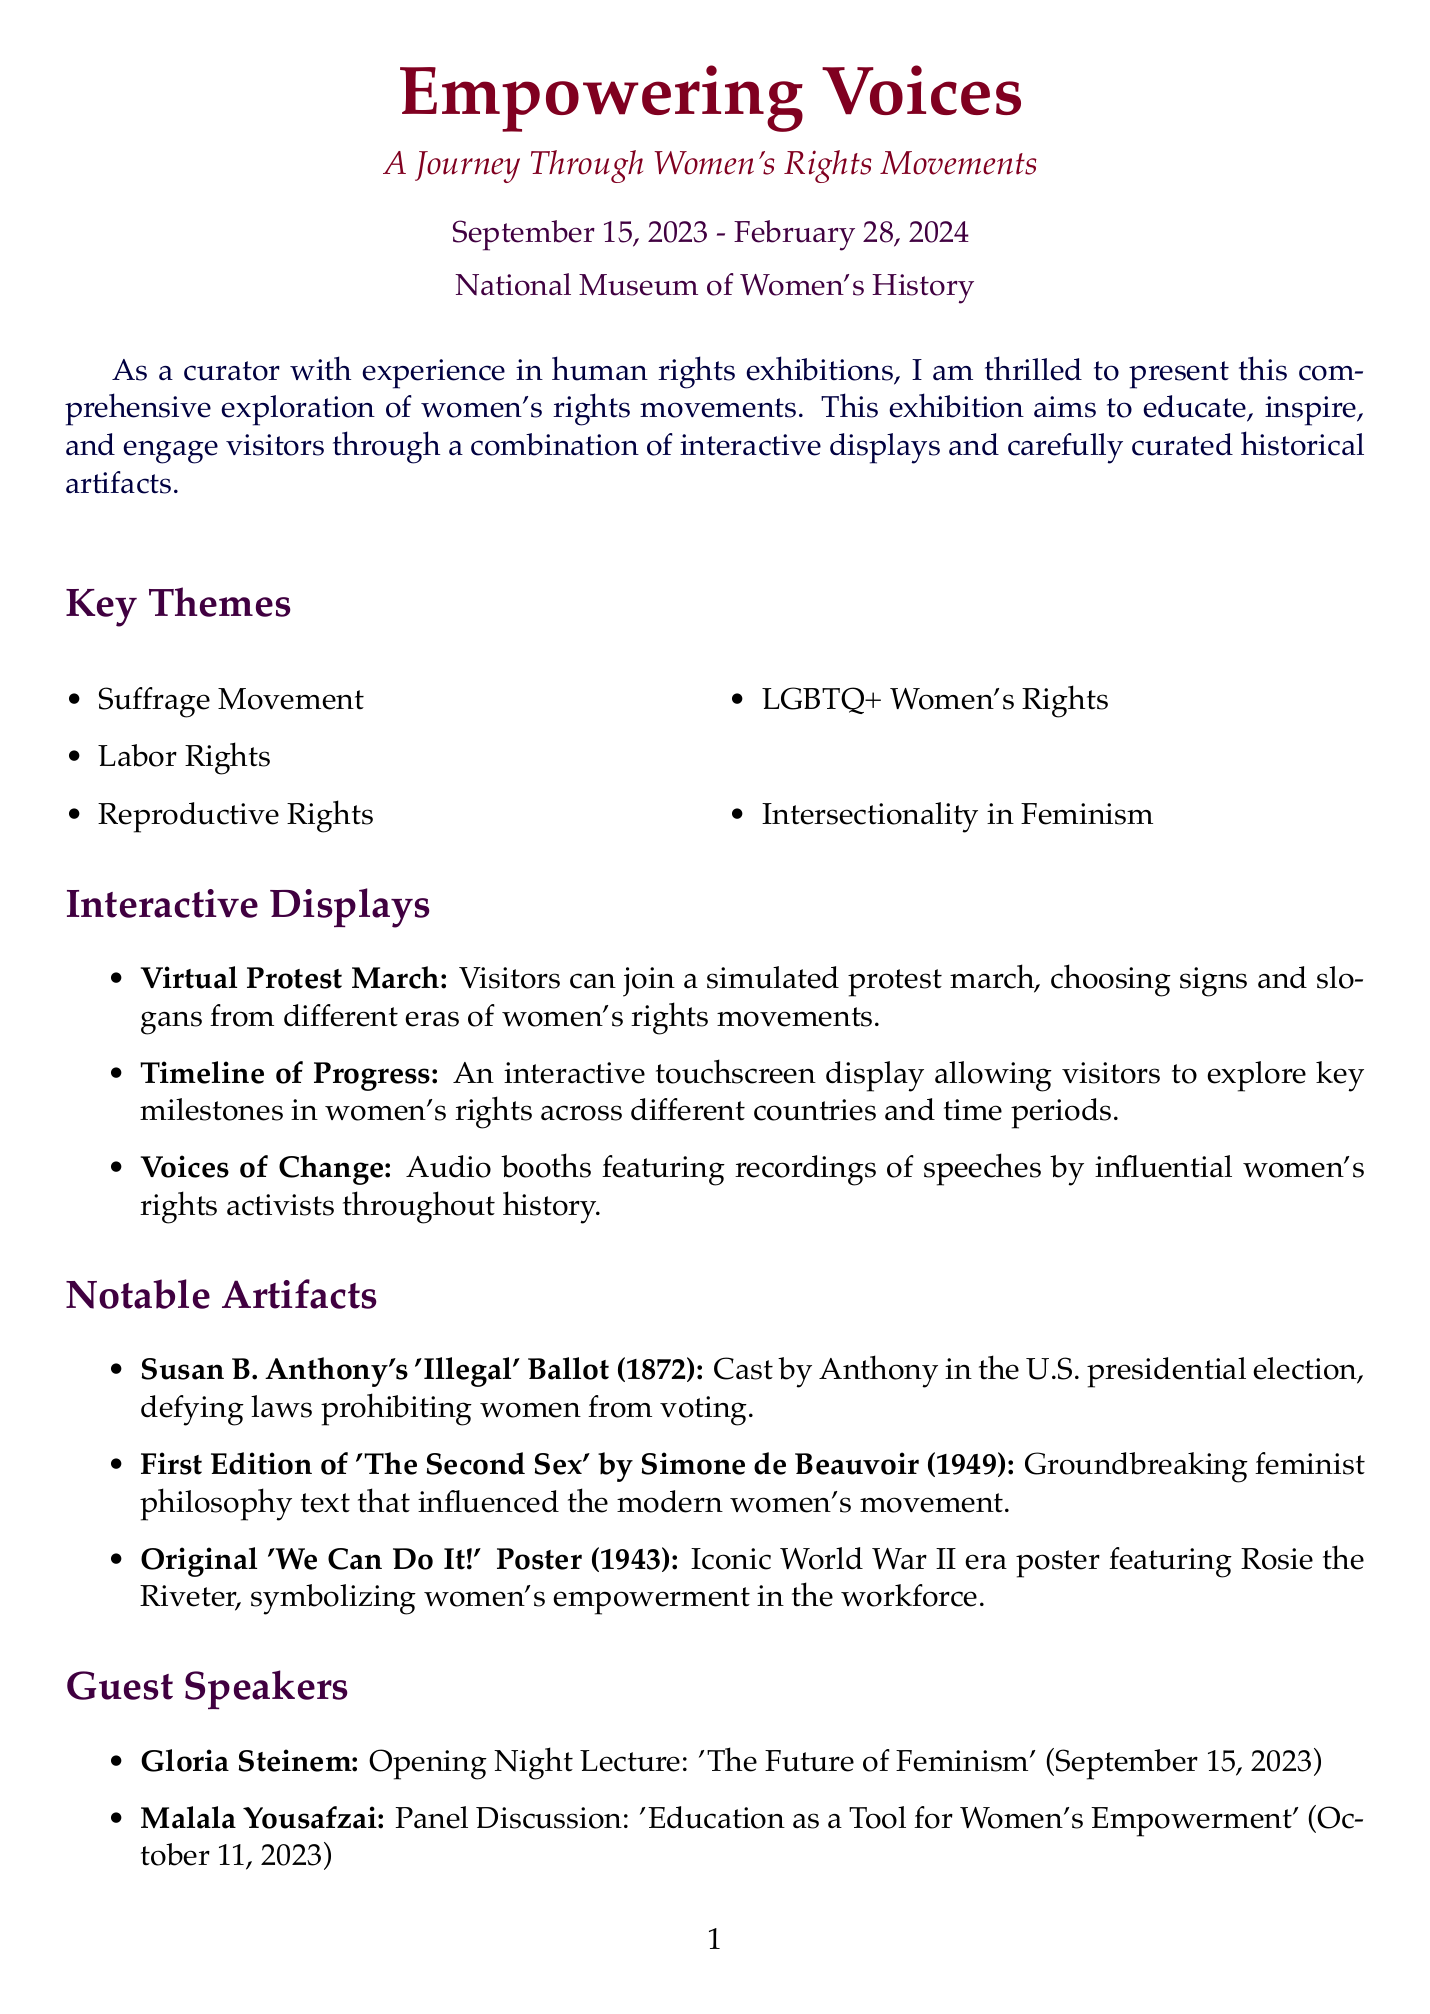what are the exhibition dates? The exhibition dates are listed in the document as "September 15, 2023 - February 28, 2024."
Answer: September 15, 2023 - February 28, 2024 who is the curator? The curator is mentioned in the document as someone with experience in human rights exhibitions, but their specific name is not provided.
Answer: Not specified what is the title of the opening night lecture? The document specifies the title of the opening night lecture given by Gloria Steinem.
Answer: The Future of Feminism how many interactive displays are there? The document lists three interactive displays under the relevant section.
Answer: 3 which organization contributed global statistics for the exhibition? The document states that the United Nations Entity for Gender Equality and the Empowerment of Women (UN Women) contributed global statistics.
Answer: UN Women what is the significance of Susan B. Anthony's 'Illegal' Ballot? The document describes the importance of this artifact in the context of women's voting rights.
Answer: Defying laws prohibiting women from voting how often does the workshop on intersectionality occur? The frequency of the workshop is specified in the educational programs section of the document.
Answer: Bi-weekly what accessibility feature is mentioned for visually impaired visitors? The document lists specific accessibility features, one of which is aimed at visually impaired visitors.
Answer: Audio descriptions 